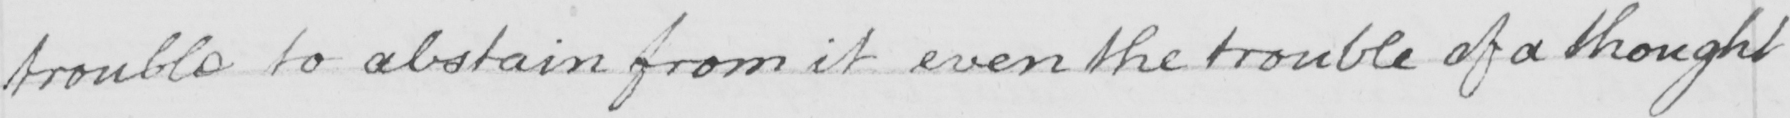Please provide the text content of this handwritten line. trouble to abstain from it even the trouble of a thought 